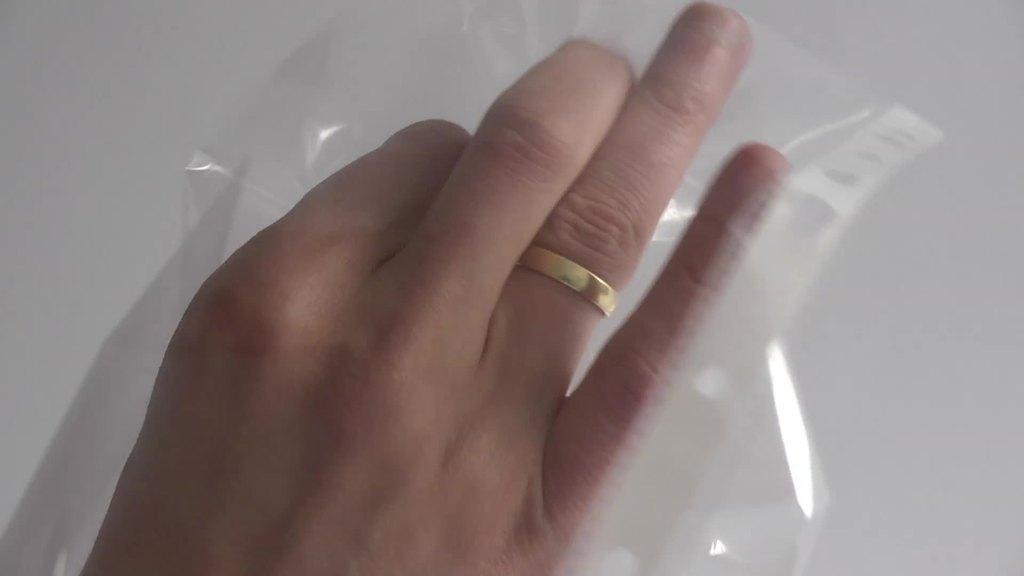How would you summarize this image in a sentence or two? In the image there is a hand of a person and also there is a ring on the finger. And there is a cover. 